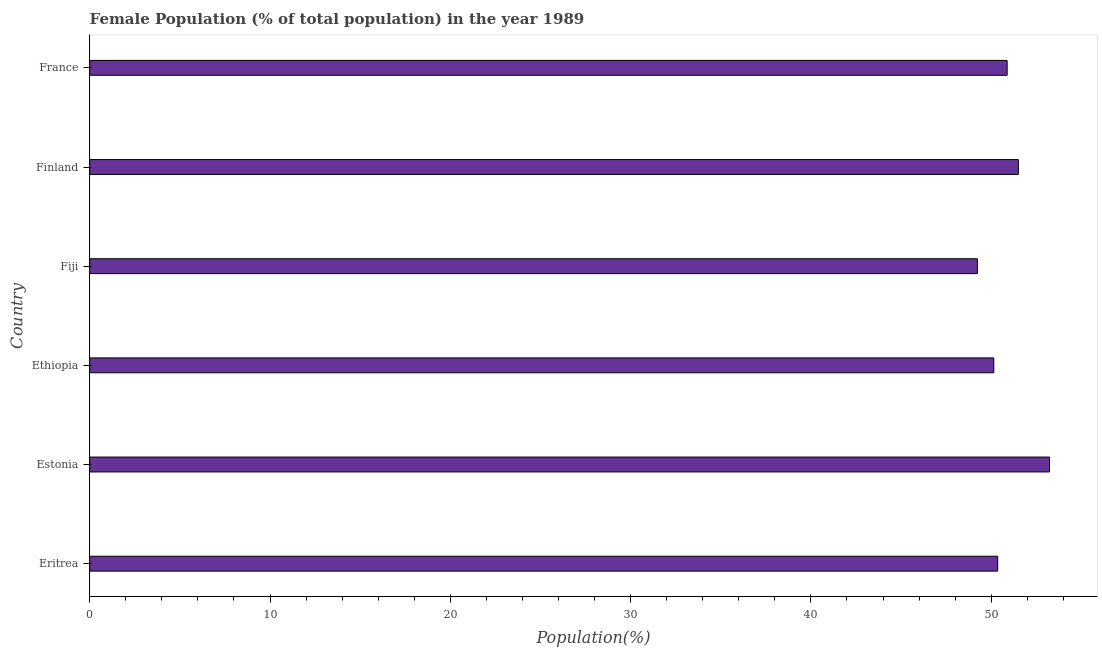Does the graph contain any zero values?
Your answer should be compact. No. Does the graph contain grids?
Your response must be concise. No. What is the title of the graph?
Provide a succinct answer. Female Population (% of total population) in the year 1989. What is the label or title of the X-axis?
Offer a terse response. Population(%). What is the female population in France?
Provide a short and direct response. 50.88. Across all countries, what is the maximum female population?
Keep it short and to the point. 53.23. Across all countries, what is the minimum female population?
Provide a succinct answer. 49.23. In which country was the female population maximum?
Ensure brevity in your answer.  Estonia. In which country was the female population minimum?
Your response must be concise. Fiji. What is the sum of the female population?
Provide a short and direct response. 305.35. What is the difference between the female population in Estonia and Ethiopia?
Keep it short and to the point. 3.09. What is the average female population per country?
Your answer should be very brief. 50.89. What is the median female population?
Your answer should be very brief. 50.62. In how many countries, is the female population greater than 4 %?
Your response must be concise. 6. What is the ratio of the female population in Fiji to that in France?
Provide a short and direct response. 0.97. Is the female population in Ethiopia less than that in Finland?
Your answer should be compact. Yes. Is the difference between the female population in Ethiopia and Fiji greater than the difference between any two countries?
Give a very brief answer. No. What is the difference between the highest and the second highest female population?
Ensure brevity in your answer.  1.73. What is the difference between the highest and the lowest female population?
Your answer should be very brief. 4. Are all the bars in the graph horizontal?
Provide a succinct answer. Yes. What is the difference between two consecutive major ticks on the X-axis?
Keep it short and to the point. 10. Are the values on the major ticks of X-axis written in scientific E-notation?
Your answer should be compact. No. What is the Population(%) of Eritrea?
Make the answer very short. 50.36. What is the Population(%) of Estonia?
Your response must be concise. 53.23. What is the Population(%) of Ethiopia?
Your answer should be compact. 50.14. What is the Population(%) of Fiji?
Offer a terse response. 49.23. What is the Population(%) in Finland?
Your response must be concise. 51.51. What is the Population(%) in France?
Keep it short and to the point. 50.88. What is the difference between the Population(%) in Eritrea and Estonia?
Make the answer very short. -2.87. What is the difference between the Population(%) in Eritrea and Ethiopia?
Your answer should be very brief. 0.22. What is the difference between the Population(%) in Eritrea and Fiji?
Offer a terse response. 1.13. What is the difference between the Population(%) in Eritrea and Finland?
Make the answer very short. -1.15. What is the difference between the Population(%) in Eritrea and France?
Ensure brevity in your answer.  -0.52. What is the difference between the Population(%) in Estonia and Ethiopia?
Ensure brevity in your answer.  3.09. What is the difference between the Population(%) in Estonia and Fiji?
Provide a short and direct response. 4. What is the difference between the Population(%) in Estonia and Finland?
Keep it short and to the point. 1.73. What is the difference between the Population(%) in Estonia and France?
Your answer should be compact. 2.35. What is the difference between the Population(%) in Ethiopia and Fiji?
Keep it short and to the point. 0.91. What is the difference between the Population(%) in Ethiopia and Finland?
Provide a short and direct response. -1.36. What is the difference between the Population(%) in Ethiopia and France?
Your response must be concise. -0.74. What is the difference between the Population(%) in Fiji and Finland?
Your response must be concise. -2.27. What is the difference between the Population(%) in Fiji and France?
Provide a short and direct response. -1.65. What is the difference between the Population(%) in Finland and France?
Offer a terse response. 0.62. What is the ratio of the Population(%) in Eritrea to that in Estonia?
Keep it short and to the point. 0.95. What is the ratio of the Population(%) in Eritrea to that in Finland?
Your response must be concise. 0.98. What is the ratio of the Population(%) in Estonia to that in Ethiopia?
Make the answer very short. 1.06. What is the ratio of the Population(%) in Estonia to that in Fiji?
Provide a succinct answer. 1.08. What is the ratio of the Population(%) in Estonia to that in Finland?
Provide a succinct answer. 1.03. What is the ratio of the Population(%) in Estonia to that in France?
Offer a terse response. 1.05. What is the ratio of the Population(%) in Ethiopia to that in Fiji?
Your answer should be compact. 1.02. What is the ratio of the Population(%) in Ethiopia to that in Finland?
Your answer should be very brief. 0.97. What is the ratio of the Population(%) in Ethiopia to that in France?
Your response must be concise. 0.98. What is the ratio of the Population(%) in Fiji to that in Finland?
Offer a very short reply. 0.96. What is the ratio of the Population(%) in Finland to that in France?
Offer a very short reply. 1.01. 